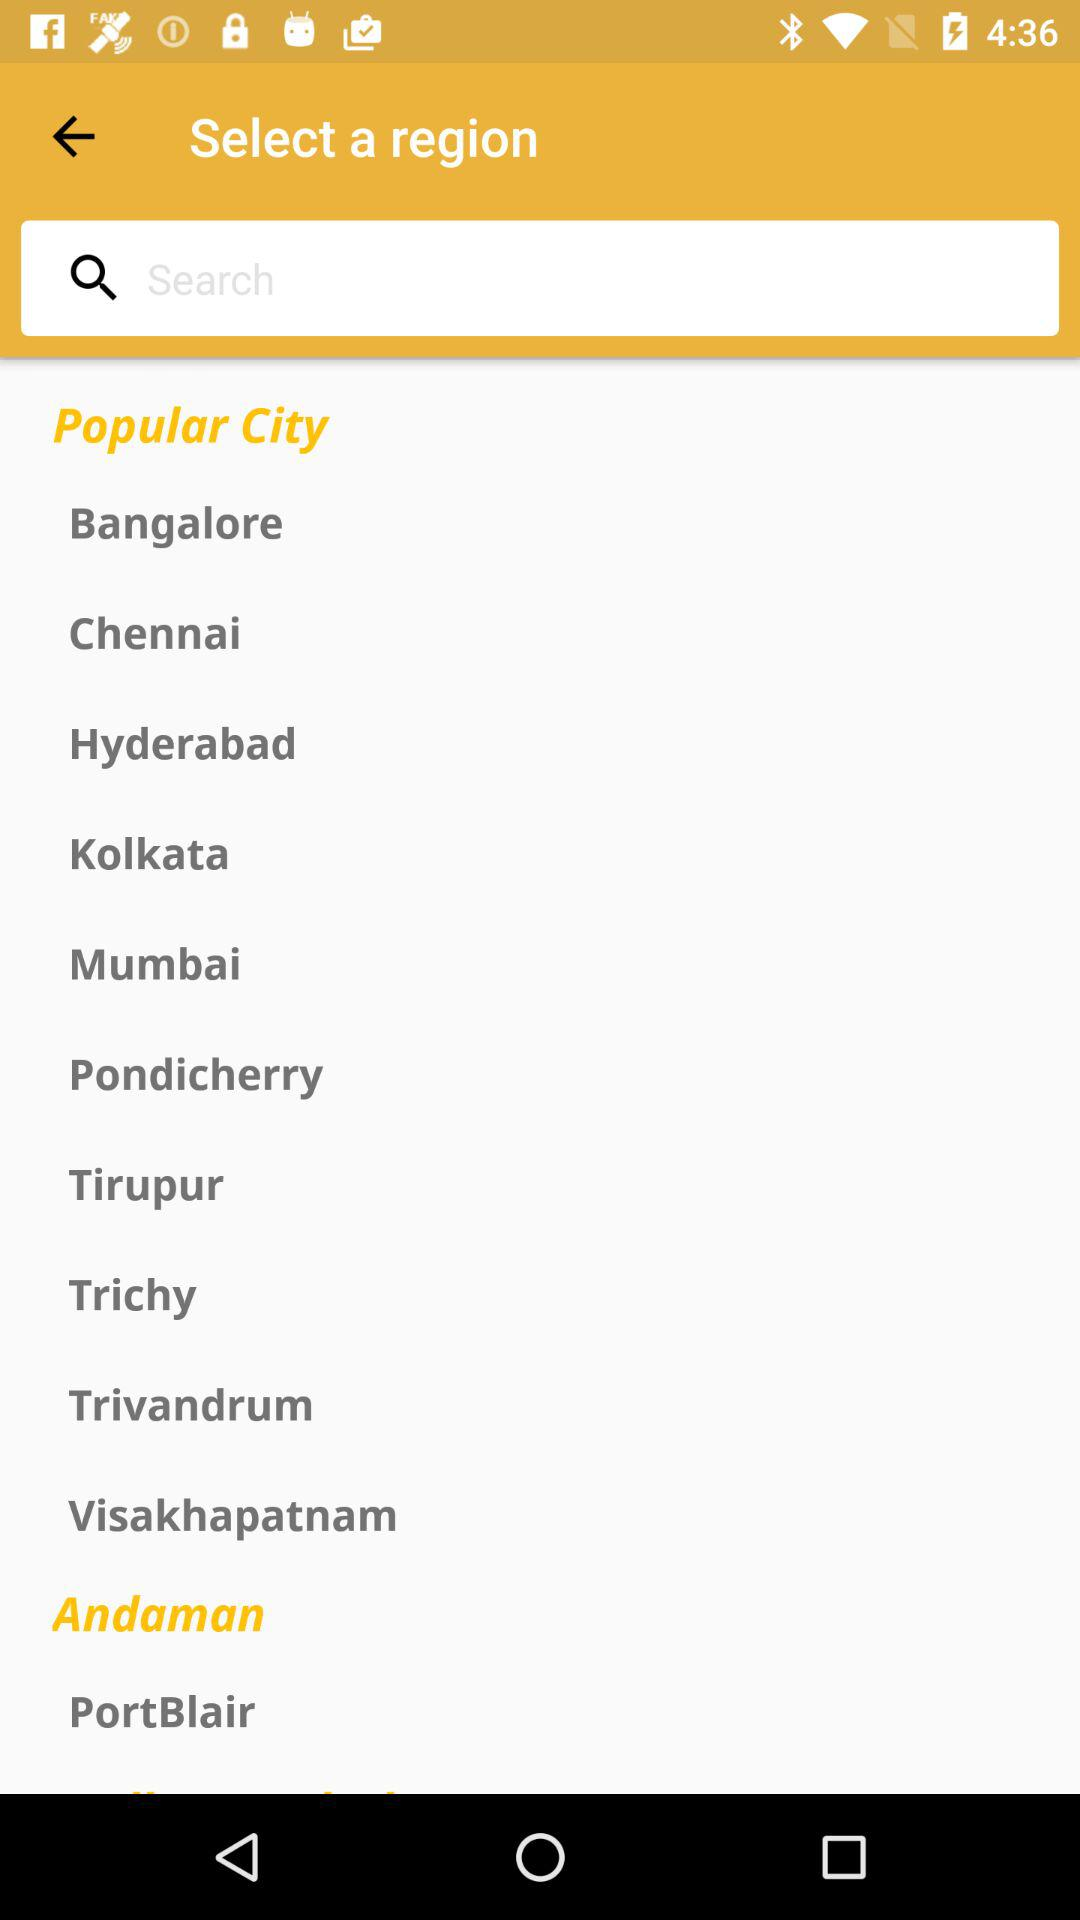What is the selected city? The selected city is "Andaman". 